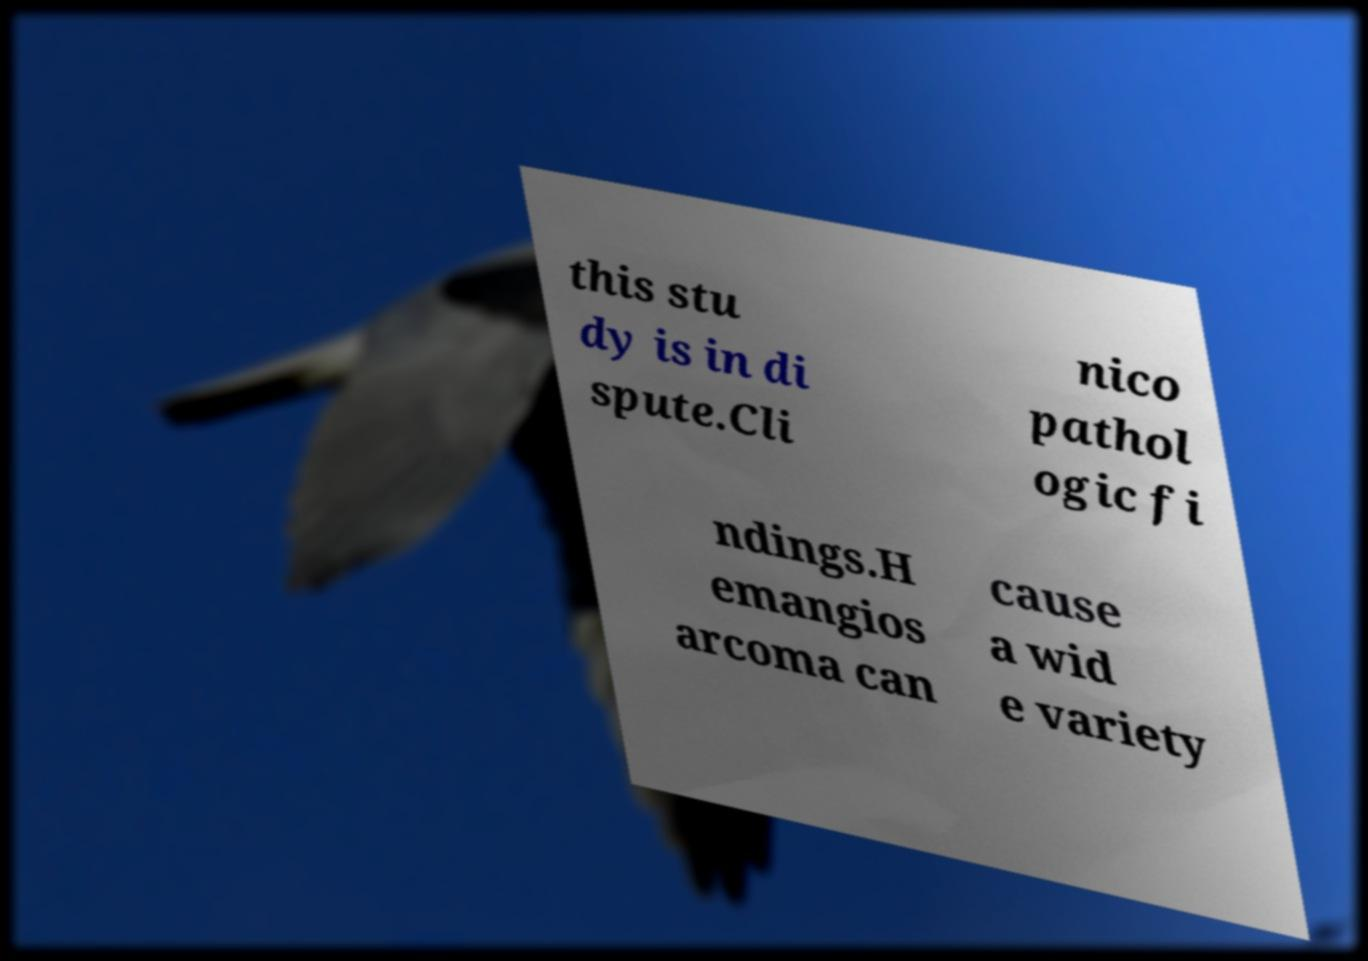There's text embedded in this image that I need extracted. Can you transcribe it verbatim? this stu dy is in di spute.Cli nico pathol ogic fi ndings.H emangios arcoma can cause a wid e variety 